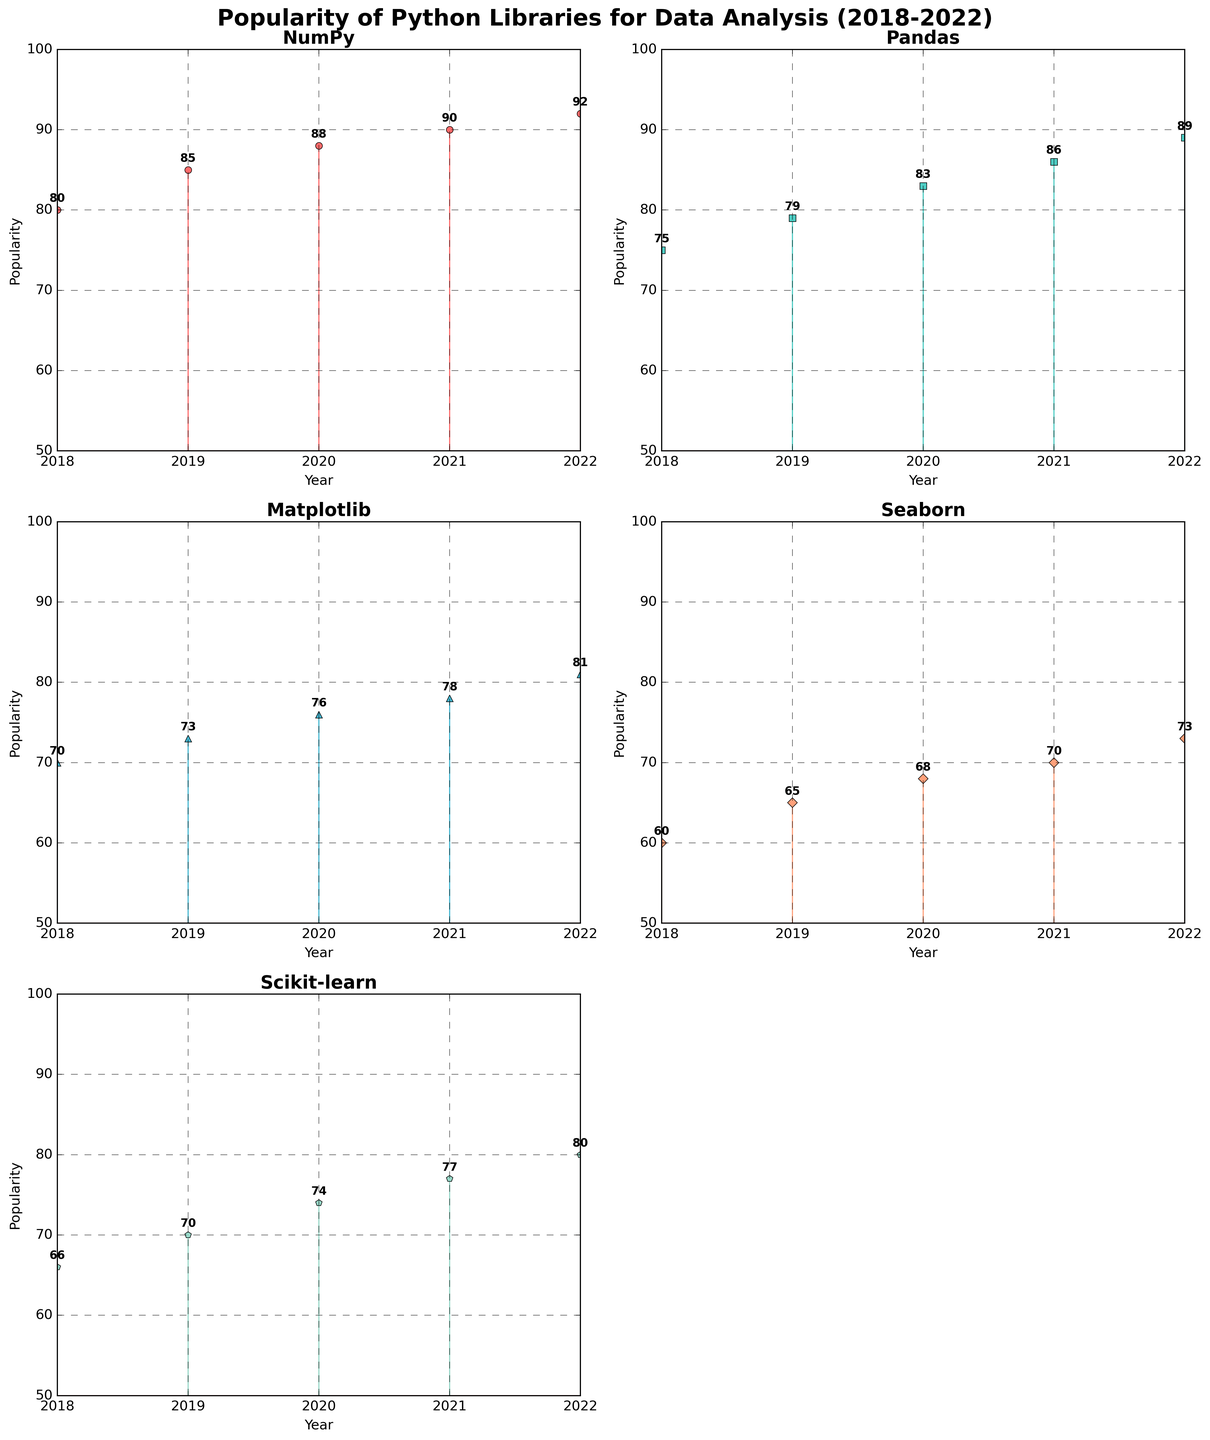Which library had the highest popularity in 2022? From the subplots, you can see each library's popularity values annotated for the year 2022. NumPy's popularity value in 2022 is 92, which is higher than the popularity values of the other libraries.
Answer: NumPy What is the difference in popularity between Pandas and Matplotlib in 2020? First, find the popularity values for Pandas and Matplotlib in 2020 from their respective subplots. Pandas has a popularity of 83 in 2020, and Matplotlib has a popularity of 76. The difference is 83 - 76 = 7.
Answer: 7 Which library showed a consistent increase in popularity every year from 2018 to 2022? By examining each subplot, you can observe the trend lines to see which library's popularity value increases every year. All libraries show a consistent increase, but you'll need to confirm it by checking the values: NumPy, Pandas, Matplotlib, Seaborn, and Scikit-learn all increase steadily each year.
Answer: All Which year did Seaborn first surpass 70 in popularity? Look at the subplot for Seaborn and check the annotations for each year. Seaborn's popularity first surpasses 70 in 2021 with a value of 70, and it increases to 73 in 2022.
Answer: 2021 What is the average popularity of NumPy over the 5 years? From the subplot for NumPy, you can see the popularity values for each year: 80, 85, 88, 90, and 92. Calculate the average: (80 + 85 + 88 + 90 + 92) / 5 = 87.
Answer: 87 How much did the popularity of Scikit-learn increase from 2018 to 2019? In the subplot for Scikit-learn, the popularity values for 2018 and 2019 are 66 and 70, respectively. The increase is 70 - 66 = 4.
Answer: 4 Which library had the lowest popularity in 2018 and what was its value? Look at the popularity values for each library in 2018 from their respective subplots. Seaborn had the lowest popularity in 2018 with a value of 60.
Answer: Seaborn, 60 By how much did Matplotlib's popularity change from 2019 to 2022? From Matplotlib's subplot, its popularity values in 2019 and 2022 are 73 and 81, respectively. The change is 81 - 73 = 8.
Answer: 8 What is the total increase in popularity for Pandas from 2018 to 2022? From Pandas' subplot, the popularity values in 2018 and 2022 are 75 and 89, respectively. The total increase is 89 - 75 = 14.
Answer: 14 Between NumPy and Seaborn, which library had more popularity in 2021 and by how much? From the subplots, NumPy's popularity in 2021 is 90, and Seaborn's popularity in 2021 is 70. The difference is 90 - 70 = 20.
Answer: NumPy, 20 